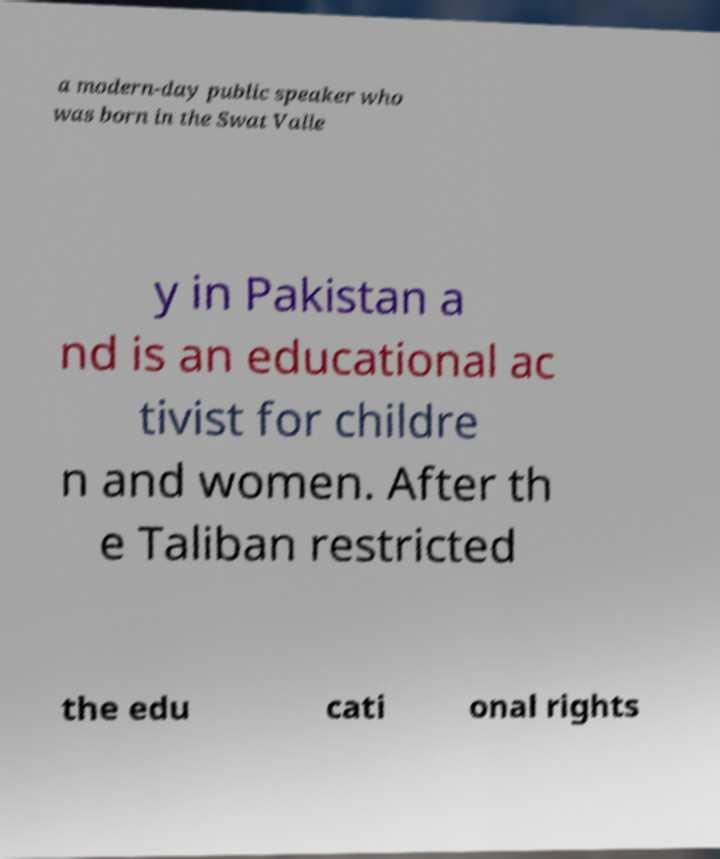Please identify and transcribe the text found in this image. a modern-day public speaker who was born in the Swat Valle y in Pakistan a nd is an educational ac tivist for childre n and women. After th e Taliban restricted the edu cati onal rights 